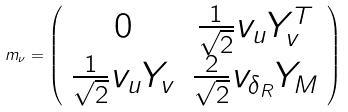<formula> <loc_0><loc_0><loc_500><loc_500>m _ { \nu } = \left ( \begin{array} { c c } 0 & \frac { 1 } { \sqrt { 2 } } v _ { u } Y _ { v } ^ { T } \\ \frac { 1 } { \sqrt { 2 } } v _ { u } Y _ { v } & \frac { 2 } { \sqrt { 2 } } v _ { \delta _ { R } } Y _ { M } \end{array} \right )</formula> 